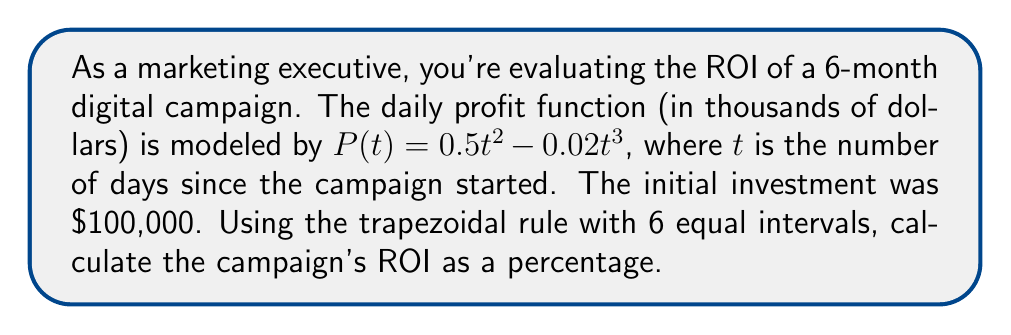Can you answer this question? 1) First, we need to calculate the total profit over the 6-month period using numerical integration.

2) The trapezoidal rule for 6 equal intervals is:

   $$\int_{a}^{b} f(x) dx \approx \frac{h}{2}[f(x_0) + 2f(x_1) + 2f(x_2) + 2f(x_3) + 2f(x_4) + 2f(x_5) + f(x_6)]$$

   where $h = \frac{b-a}{6}$ and $x_i = a + ih$

3) Here, $a=0$, $b=180$ (6 months = 180 days), so $h = 30$

4) Calculate $P(t)$ for $t = 0, 30, 60, 90, 120, 150, 180$:
   
   $P(0) = 0$
   $P(30) = 450 - 540 = -90$
   $P(60) = 1800 - 4320 = -2520$
   $P(90) = 4050 - 14580 = -10530$
   $P(120) = 7200 - 34560 = -27360$
   $P(150) = 11250 - 67500 = -56250$
   $P(180) = 16200 - 116640 = -100440$

5) Apply the trapezoidal rule:

   $$\text{Total Profit} \approx \frac{30}{2}[0 + 2(-90) + 2(-2520) + 2(-10530) + 2(-27360) + 2(-56250) + (-100440)]$$
   $$= 15[-197190] = -2,957,850$$

6) The total profit over 6 months is approximately -$2,957,850

7) ROI is calculated as: $ROI = \frac{\text{Gain from Investment} - \text{Cost of Investment}}{\text{Cost of Investment}} \times 100\%$

8) $ROI = \frac{-2,957,850 - 100,000}{100,000} \times 100\% = -3057.85\%$
Answer: -3057.85% 